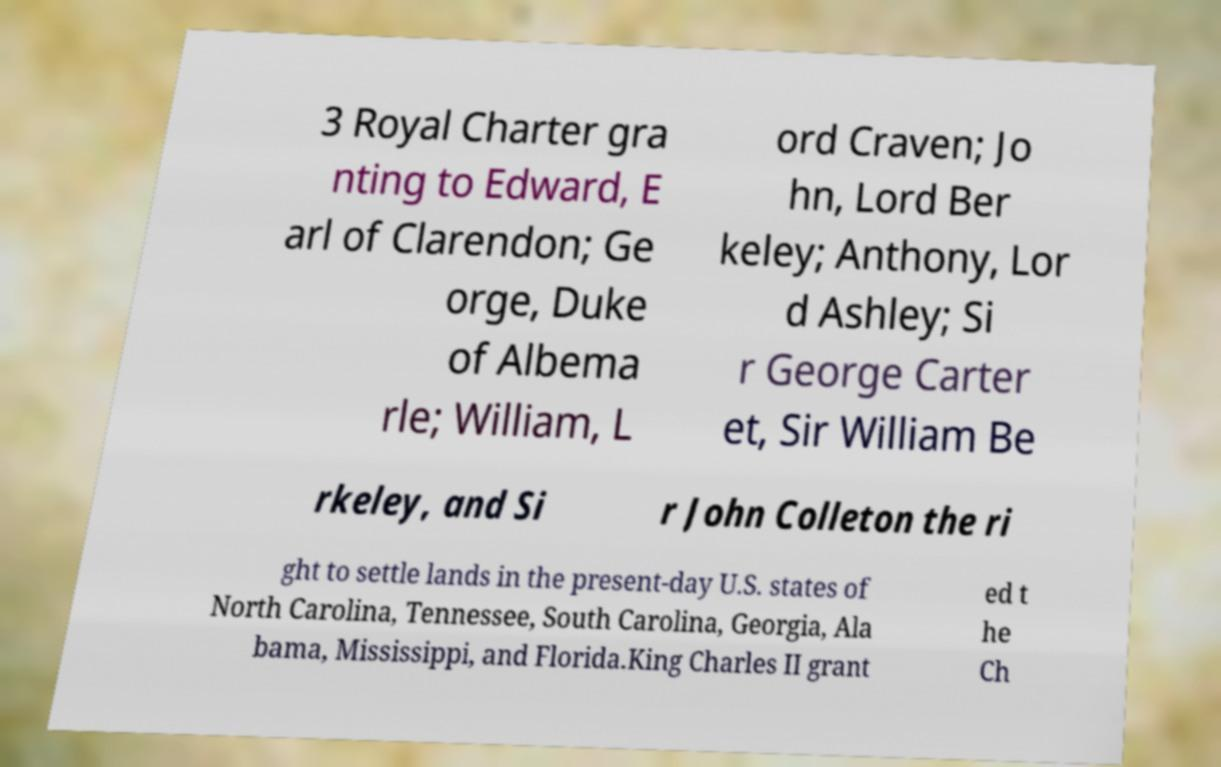Could you extract and type out the text from this image? 3 Royal Charter gra nting to Edward, E arl of Clarendon; Ge orge, Duke of Albema rle; William, L ord Craven; Jo hn, Lord Ber keley; Anthony, Lor d Ashley; Si r George Carter et, Sir William Be rkeley, and Si r John Colleton the ri ght to settle lands in the present-day U.S. states of North Carolina, Tennessee, South Carolina, Georgia, Ala bama, Mississippi, and Florida.King Charles II grant ed t he Ch 